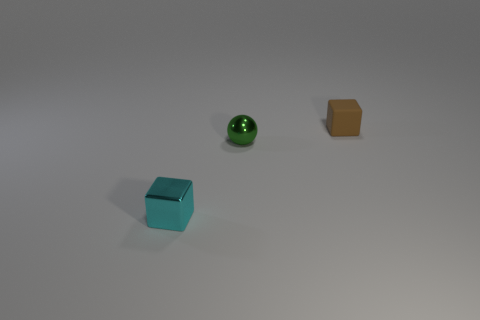There is another small object that is the same shape as the tiny brown thing; what is it made of?
Keep it short and to the point. Metal. Is the number of small green shiny objects on the right side of the matte thing greater than the number of cyan balls?
Provide a succinct answer. No. Is there anything else that is the same color as the metal block?
Keep it short and to the point. No. There is a small green thing that is made of the same material as the cyan block; what is its shape?
Your answer should be very brief. Sphere. Do the small cube in front of the rubber block and the brown object have the same material?
Offer a terse response. No. Does the tiny cube in front of the tiny brown thing have the same color as the shiny thing that is right of the tiny cyan metal cube?
Offer a very short reply. No. What number of small things are both to the right of the small green metal ball and on the left side of the rubber cube?
Your response must be concise. 0. What is the material of the small cyan object?
Your answer should be very brief. Metal. What is the shape of the green thing that is the same size as the metal cube?
Ensure brevity in your answer.  Sphere. Are the small cube in front of the brown object and the tiny block that is behind the cyan shiny object made of the same material?
Your response must be concise. No. 